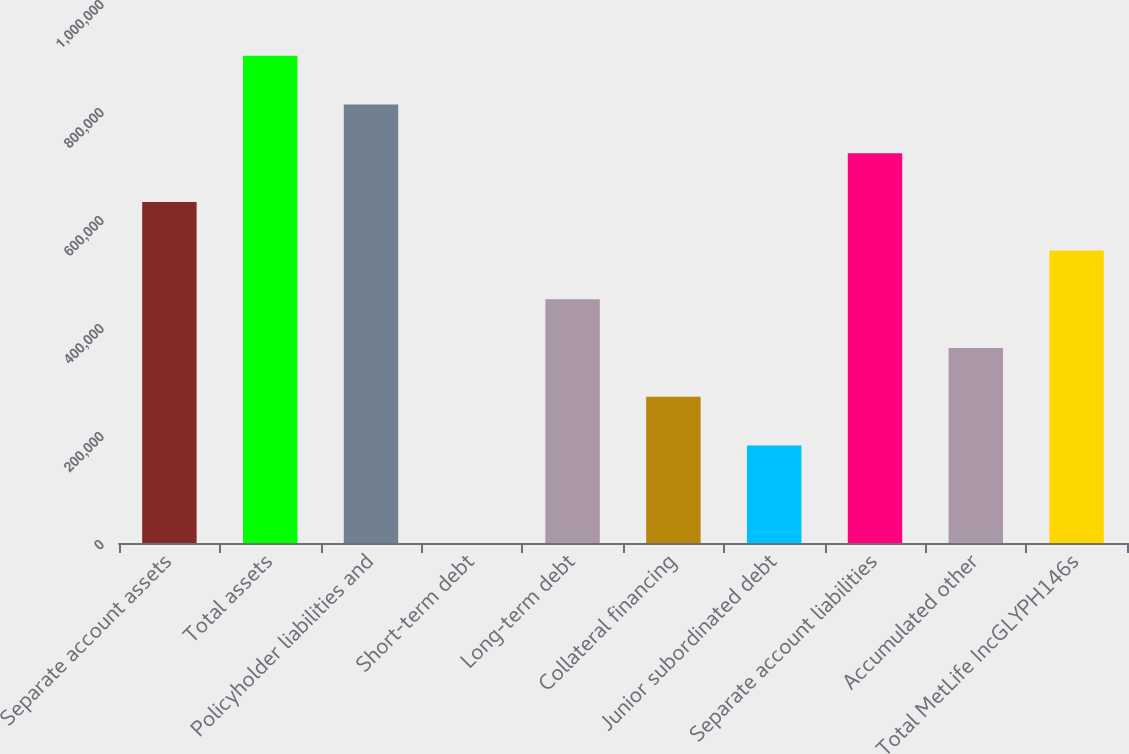Convert chart to OTSL. <chart><loc_0><loc_0><loc_500><loc_500><bar_chart><fcel>Separate account assets<fcel>Total assets<fcel>Policyholder liabilities and<fcel>Short-term debt<fcel>Long-term debt<fcel>Collateral financing<fcel>Junior subordinated debt<fcel>Separate account liabilities<fcel>Accumulated other<fcel>Total MetLife IncGLYPH146s<nl><fcel>631666<fcel>902337<fcel>812113<fcel>100<fcel>451218<fcel>270771<fcel>180547<fcel>721890<fcel>360995<fcel>541442<nl></chart> 